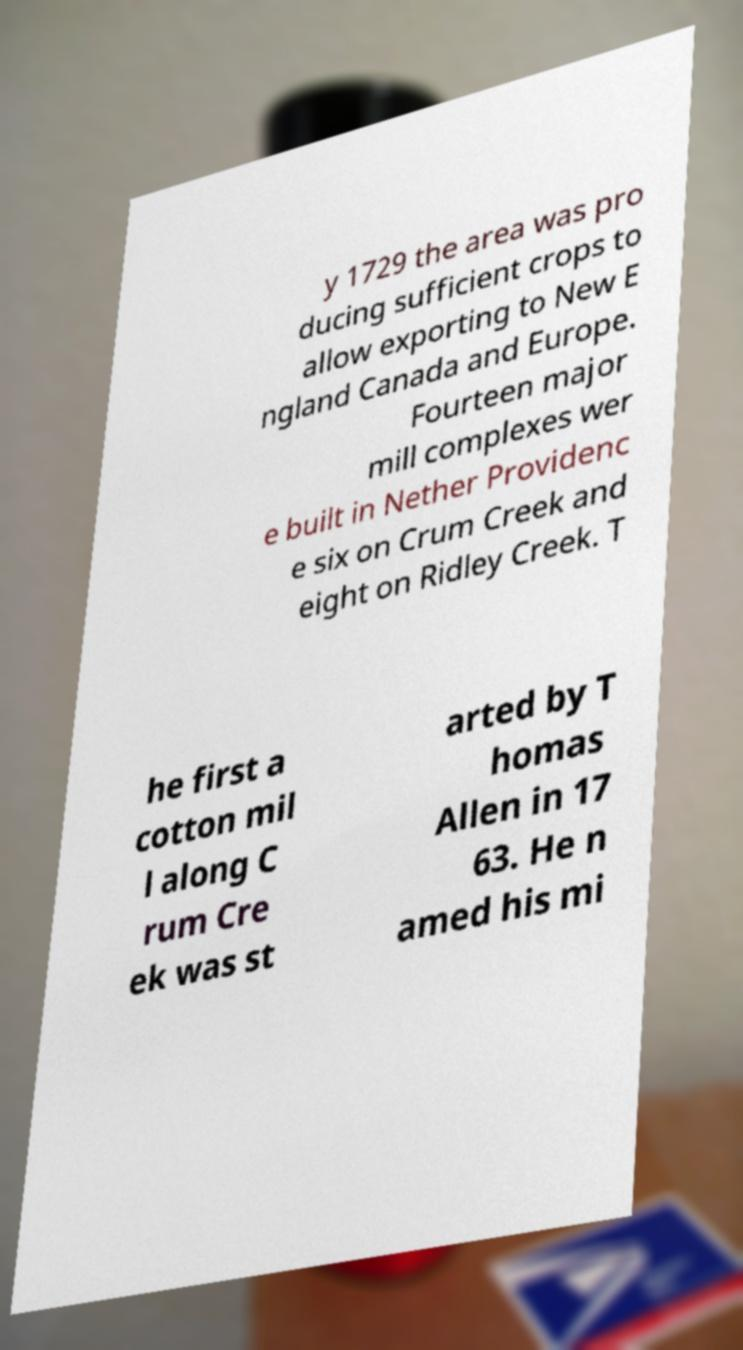There's text embedded in this image that I need extracted. Can you transcribe it verbatim? y 1729 the area was pro ducing sufficient crops to allow exporting to New E ngland Canada and Europe. Fourteen major mill complexes wer e built in Nether Providenc e six on Crum Creek and eight on Ridley Creek. T he first a cotton mil l along C rum Cre ek was st arted by T homas Allen in 17 63. He n amed his mi 